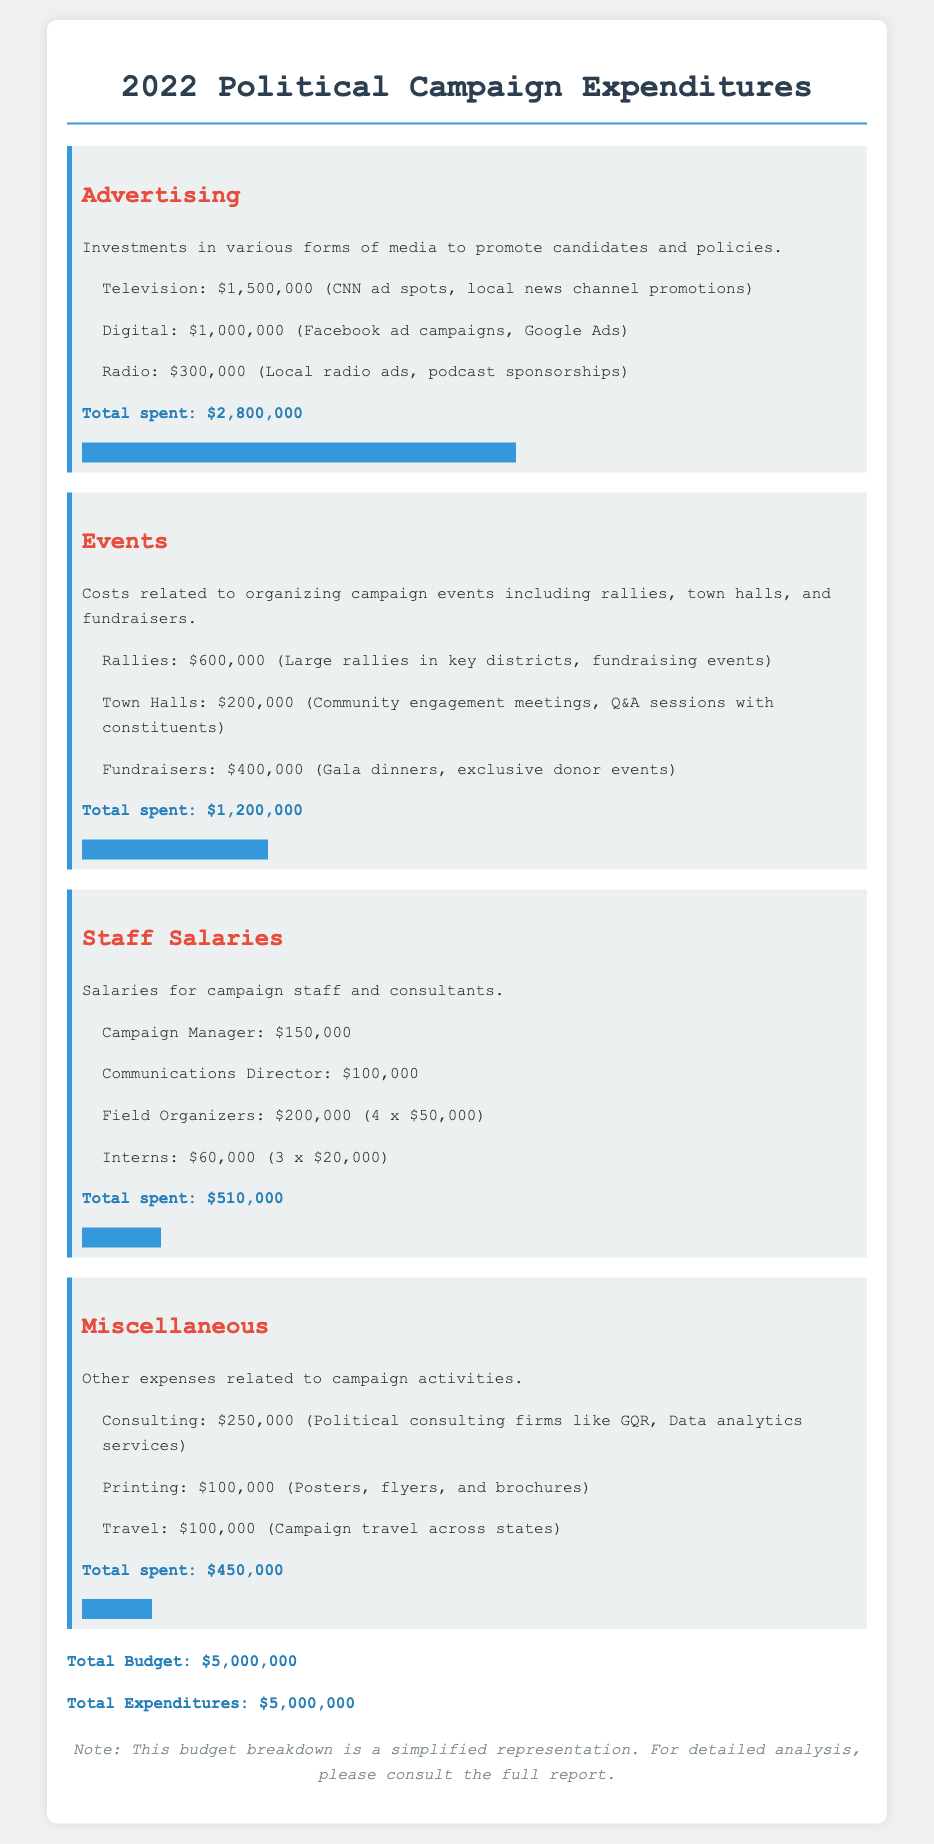What is the total spent on Advertising? The total spent on Advertising is found in the breakdown section, which lists all related costs, summing up to $2,800,000.
Answer: $2,800,000 How much was spent on Events? The document provides a summary of expenditures for Events, which is listed as $1,200,000.
Answer: $1,200,000 What is the salary of the Campaign Manager? The salary for the Campaign Manager is specifically mentioned in the Staff Salaries section as $150,000.
Answer: $150,000 What is the total budget for the campaign? The total budget for the campaign is provided at the end of the document as $5,000,000.
Answer: $5,000,000 Which category had the lowest spending? By comparing the total expenditures for each category, Miscellaneous shows the lowest spending at $450,000.
Answer: Miscellaneous How much was allocated for Digital Advertising? The digital advertising expenditure is stated as $1,000,000 in the Advertising section.
Answer: $1,000,000 What is the expenditure on Consulting services? The budget section for Miscellaneous indicates that Consulting costs $250,000.
Answer: $250,000 How many Field Organizers are accounted for in the salary section? The Staff Salaries section notes there are 4 Field Organizers, each earning $50,000.
Answer: 4 What is the total spending on Staff Salaries? The total for Staff Salaries is summarized to be $510,000 in the document.
Answer: $510,000 